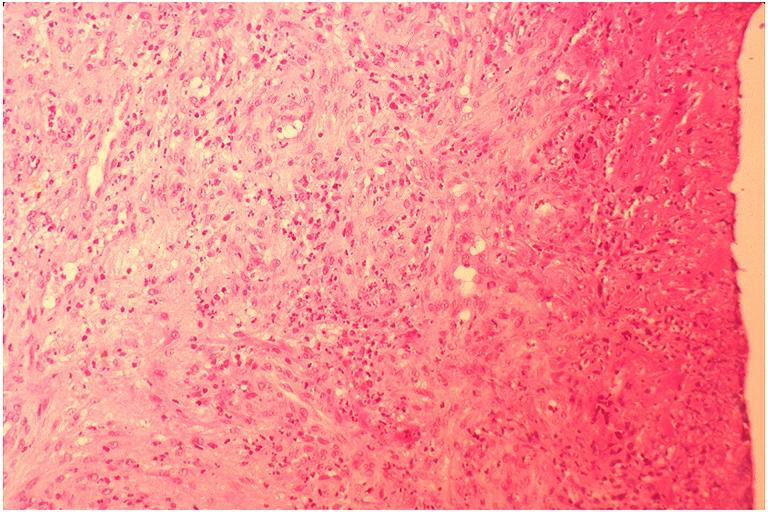s oral present?
Answer the question using a single word or phrase. Yes 